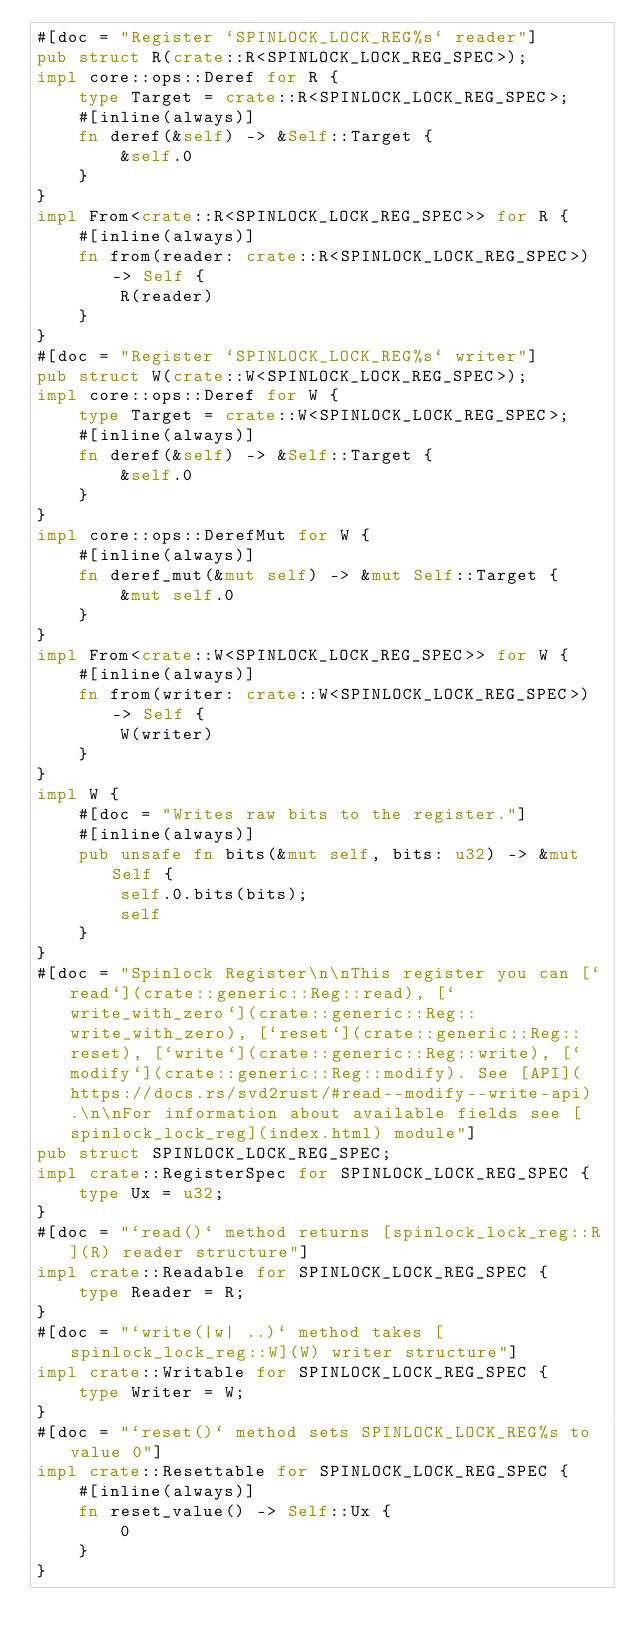<code> <loc_0><loc_0><loc_500><loc_500><_Rust_>#[doc = "Register `SPINLOCK_LOCK_REG%s` reader"]
pub struct R(crate::R<SPINLOCK_LOCK_REG_SPEC>);
impl core::ops::Deref for R {
    type Target = crate::R<SPINLOCK_LOCK_REG_SPEC>;
    #[inline(always)]
    fn deref(&self) -> &Self::Target {
        &self.0
    }
}
impl From<crate::R<SPINLOCK_LOCK_REG_SPEC>> for R {
    #[inline(always)]
    fn from(reader: crate::R<SPINLOCK_LOCK_REG_SPEC>) -> Self {
        R(reader)
    }
}
#[doc = "Register `SPINLOCK_LOCK_REG%s` writer"]
pub struct W(crate::W<SPINLOCK_LOCK_REG_SPEC>);
impl core::ops::Deref for W {
    type Target = crate::W<SPINLOCK_LOCK_REG_SPEC>;
    #[inline(always)]
    fn deref(&self) -> &Self::Target {
        &self.0
    }
}
impl core::ops::DerefMut for W {
    #[inline(always)]
    fn deref_mut(&mut self) -> &mut Self::Target {
        &mut self.0
    }
}
impl From<crate::W<SPINLOCK_LOCK_REG_SPEC>> for W {
    #[inline(always)]
    fn from(writer: crate::W<SPINLOCK_LOCK_REG_SPEC>) -> Self {
        W(writer)
    }
}
impl W {
    #[doc = "Writes raw bits to the register."]
    #[inline(always)]
    pub unsafe fn bits(&mut self, bits: u32) -> &mut Self {
        self.0.bits(bits);
        self
    }
}
#[doc = "Spinlock Register\n\nThis register you can [`read`](crate::generic::Reg::read), [`write_with_zero`](crate::generic::Reg::write_with_zero), [`reset`](crate::generic::Reg::reset), [`write`](crate::generic::Reg::write), [`modify`](crate::generic::Reg::modify). See [API](https://docs.rs/svd2rust/#read--modify--write-api).\n\nFor information about available fields see [spinlock_lock_reg](index.html) module"]
pub struct SPINLOCK_LOCK_REG_SPEC;
impl crate::RegisterSpec for SPINLOCK_LOCK_REG_SPEC {
    type Ux = u32;
}
#[doc = "`read()` method returns [spinlock_lock_reg::R](R) reader structure"]
impl crate::Readable for SPINLOCK_LOCK_REG_SPEC {
    type Reader = R;
}
#[doc = "`write(|w| ..)` method takes [spinlock_lock_reg::W](W) writer structure"]
impl crate::Writable for SPINLOCK_LOCK_REG_SPEC {
    type Writer = W;
}
#[doc = "`reset()` method sets SPINLOCK_LOCK_REG%s to value 0"]
impl crate::Resettable for SPINLOCK_LOCK_REG_SPEC {
    #[inline(always)]
    fn reset_value() -> Self::Ux {
        0
    }
}
</code> 